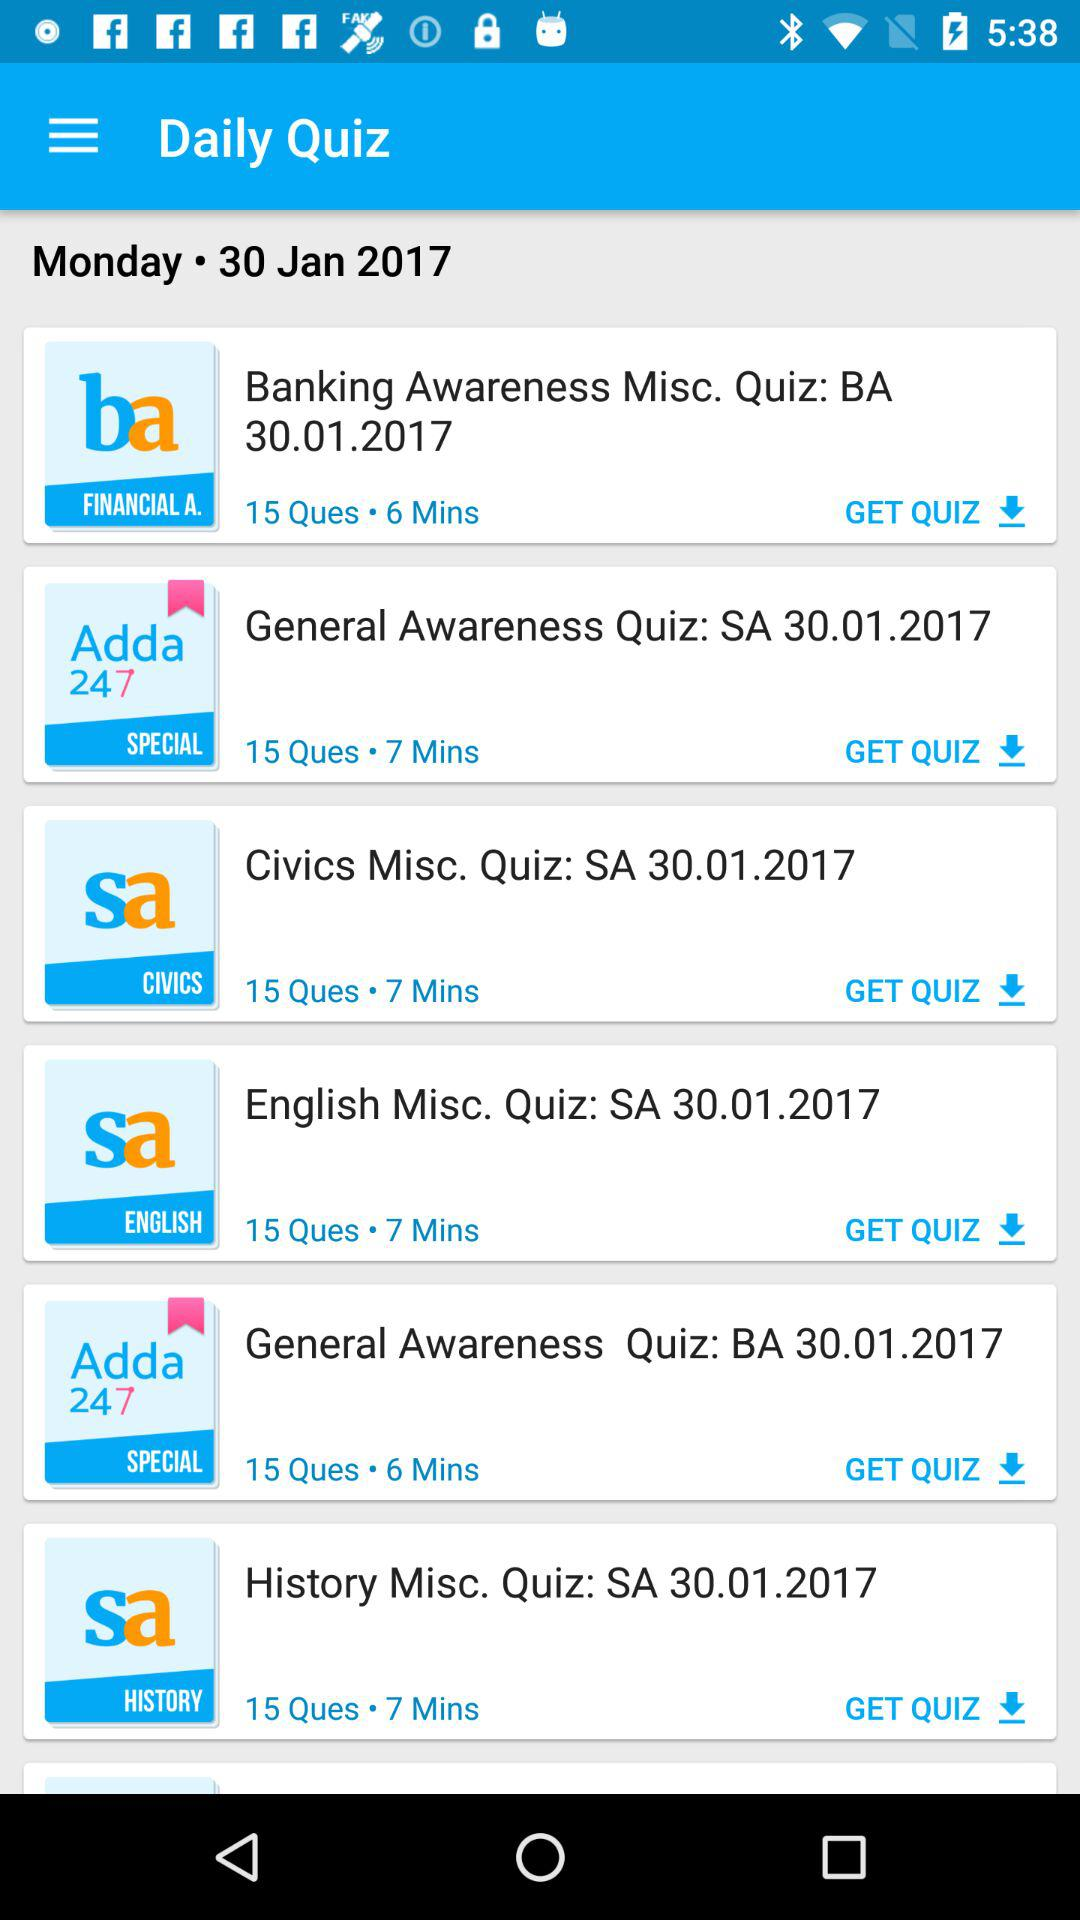How many questions are there in "English Misc. Quiz"? There are 15 questions in "English Misc. Quiz". 